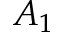<formula> <loc_0><loc_0><loc_500><loc_500>A _ { 1 }</formula> 